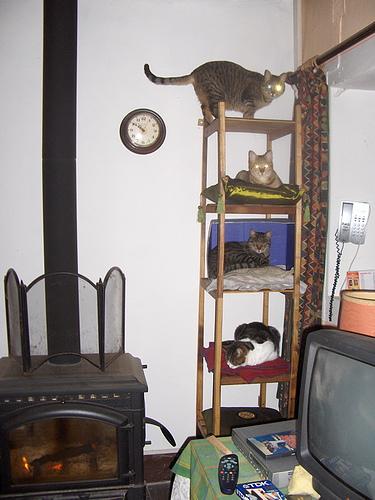Does the top cat have glowing eyes?
Keep it brief. Yes. Where are the cats?
Concise answer only. On shelves. How many cats?
Short answer required. 4. What animal is on the wall?
Short answer required. Cat. 